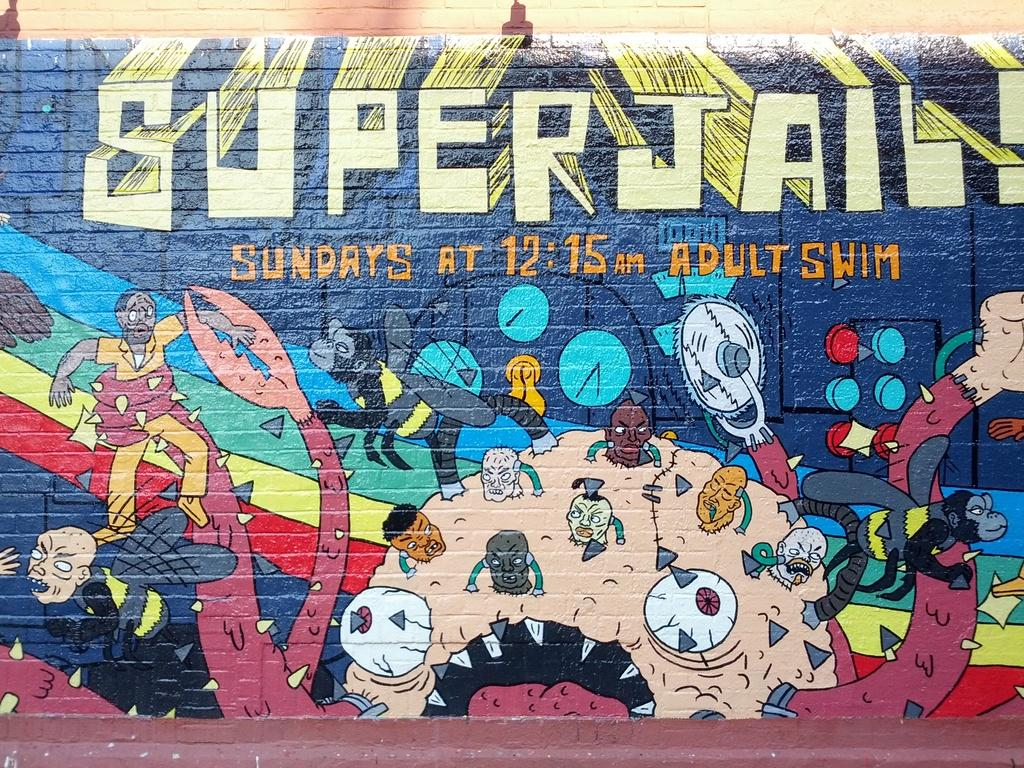What is present on the wall in the image? There is graffiti and writing on the wall in the image. Can you describe the graffiti on the wall? Unfortunately, the specific details of the graffiti cannot be determined from the provided facts. What type of writing is present on the wall? The type of writing on the wall cannot be determined from the provided facts. What type of juice is being served by the doctor in the image? There is no doctor or juice present in the image. 